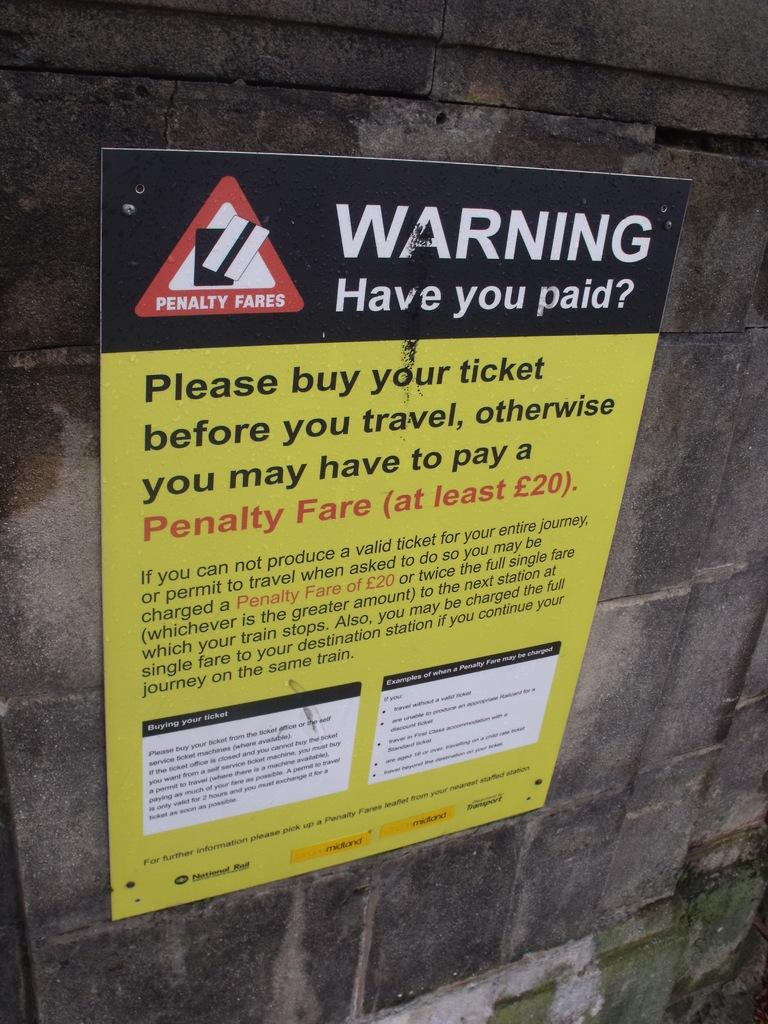<image>
Share a concise interpretation of the image provided. A sign warning train travelers to purchase their tickets before leaving. 